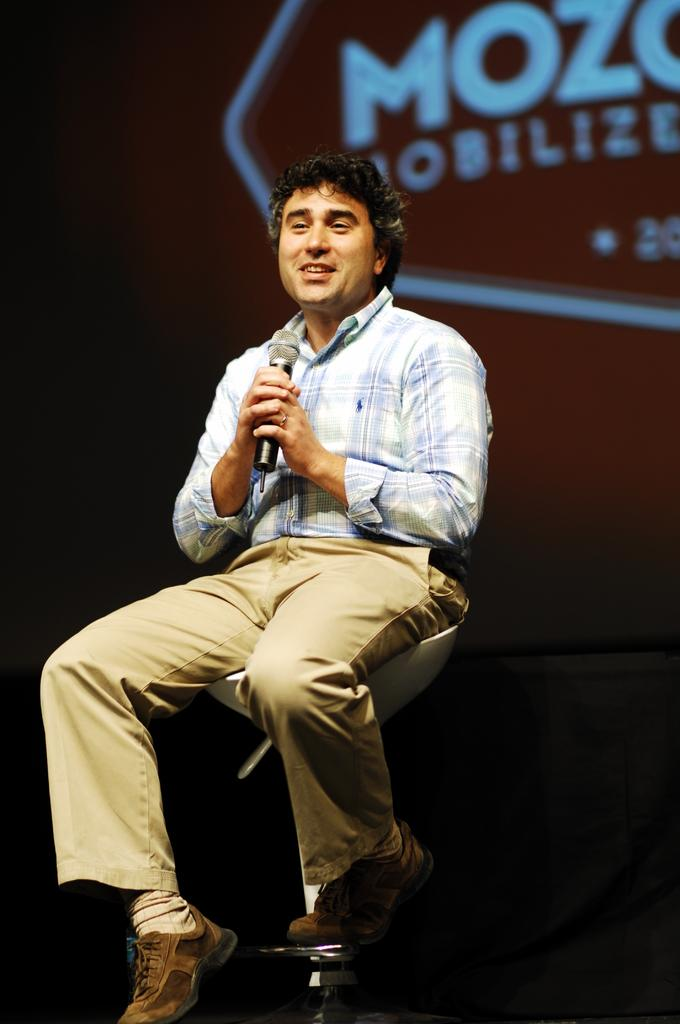What is the person in the image doing? The person is sitting in a chair and speaking in front of a microphone. Can you describe the person's position in the image? The person is sitting down while speaking into the microphone. What type of soda is being served on the stage in the image? There is no soda or stage present in the image; it only features a person sitting in a chair and speaking into a microphone. 